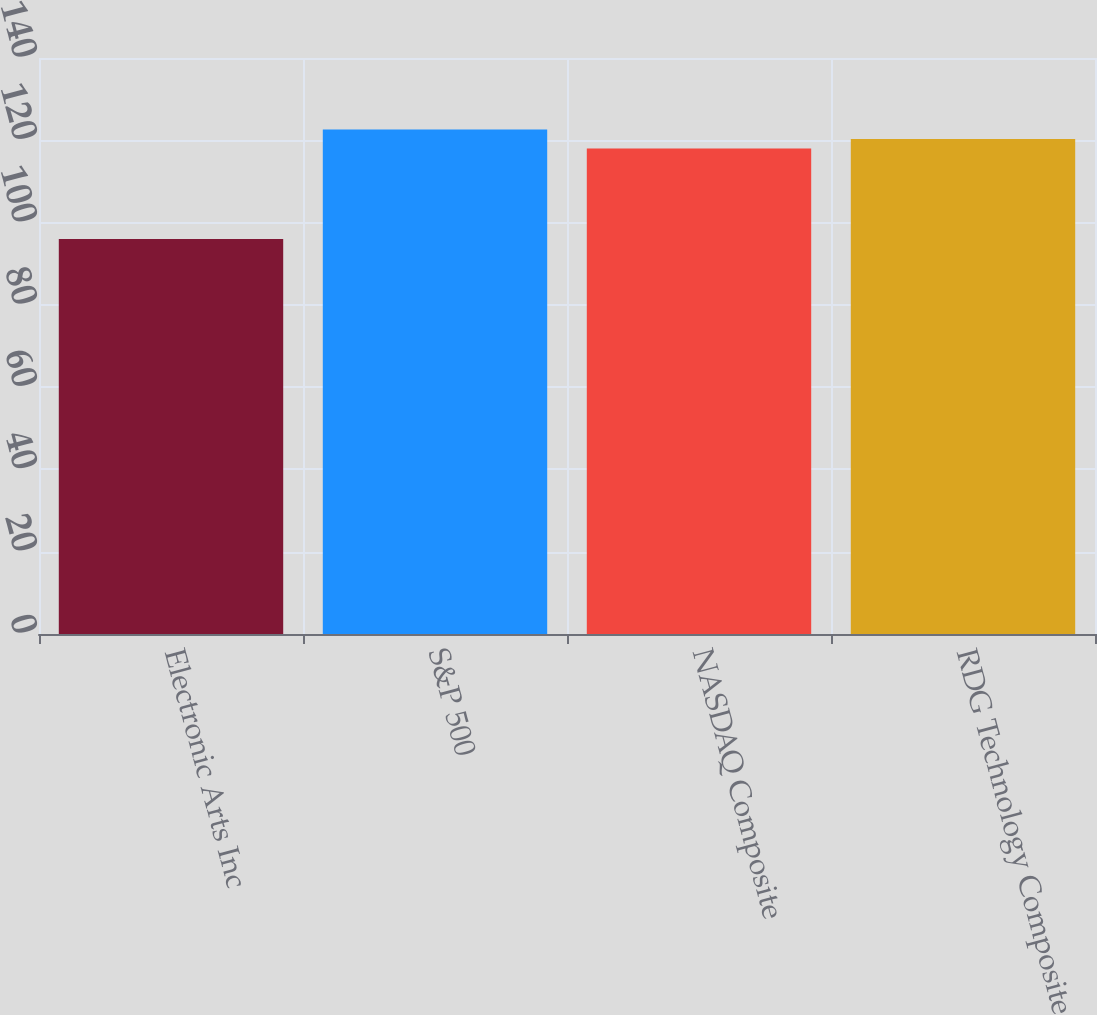<chart> <loc_0><loc_0><loc_500><loc_500><bar_chart><fcel>Electronic Arts Inc<fcel>S&P 500<fcel>NASDAQ Composite<fcel>RDG Technology Composite<nl><fcel>96<fcel>122.6<fcel>118<fcel>120.3<nl></chart> 